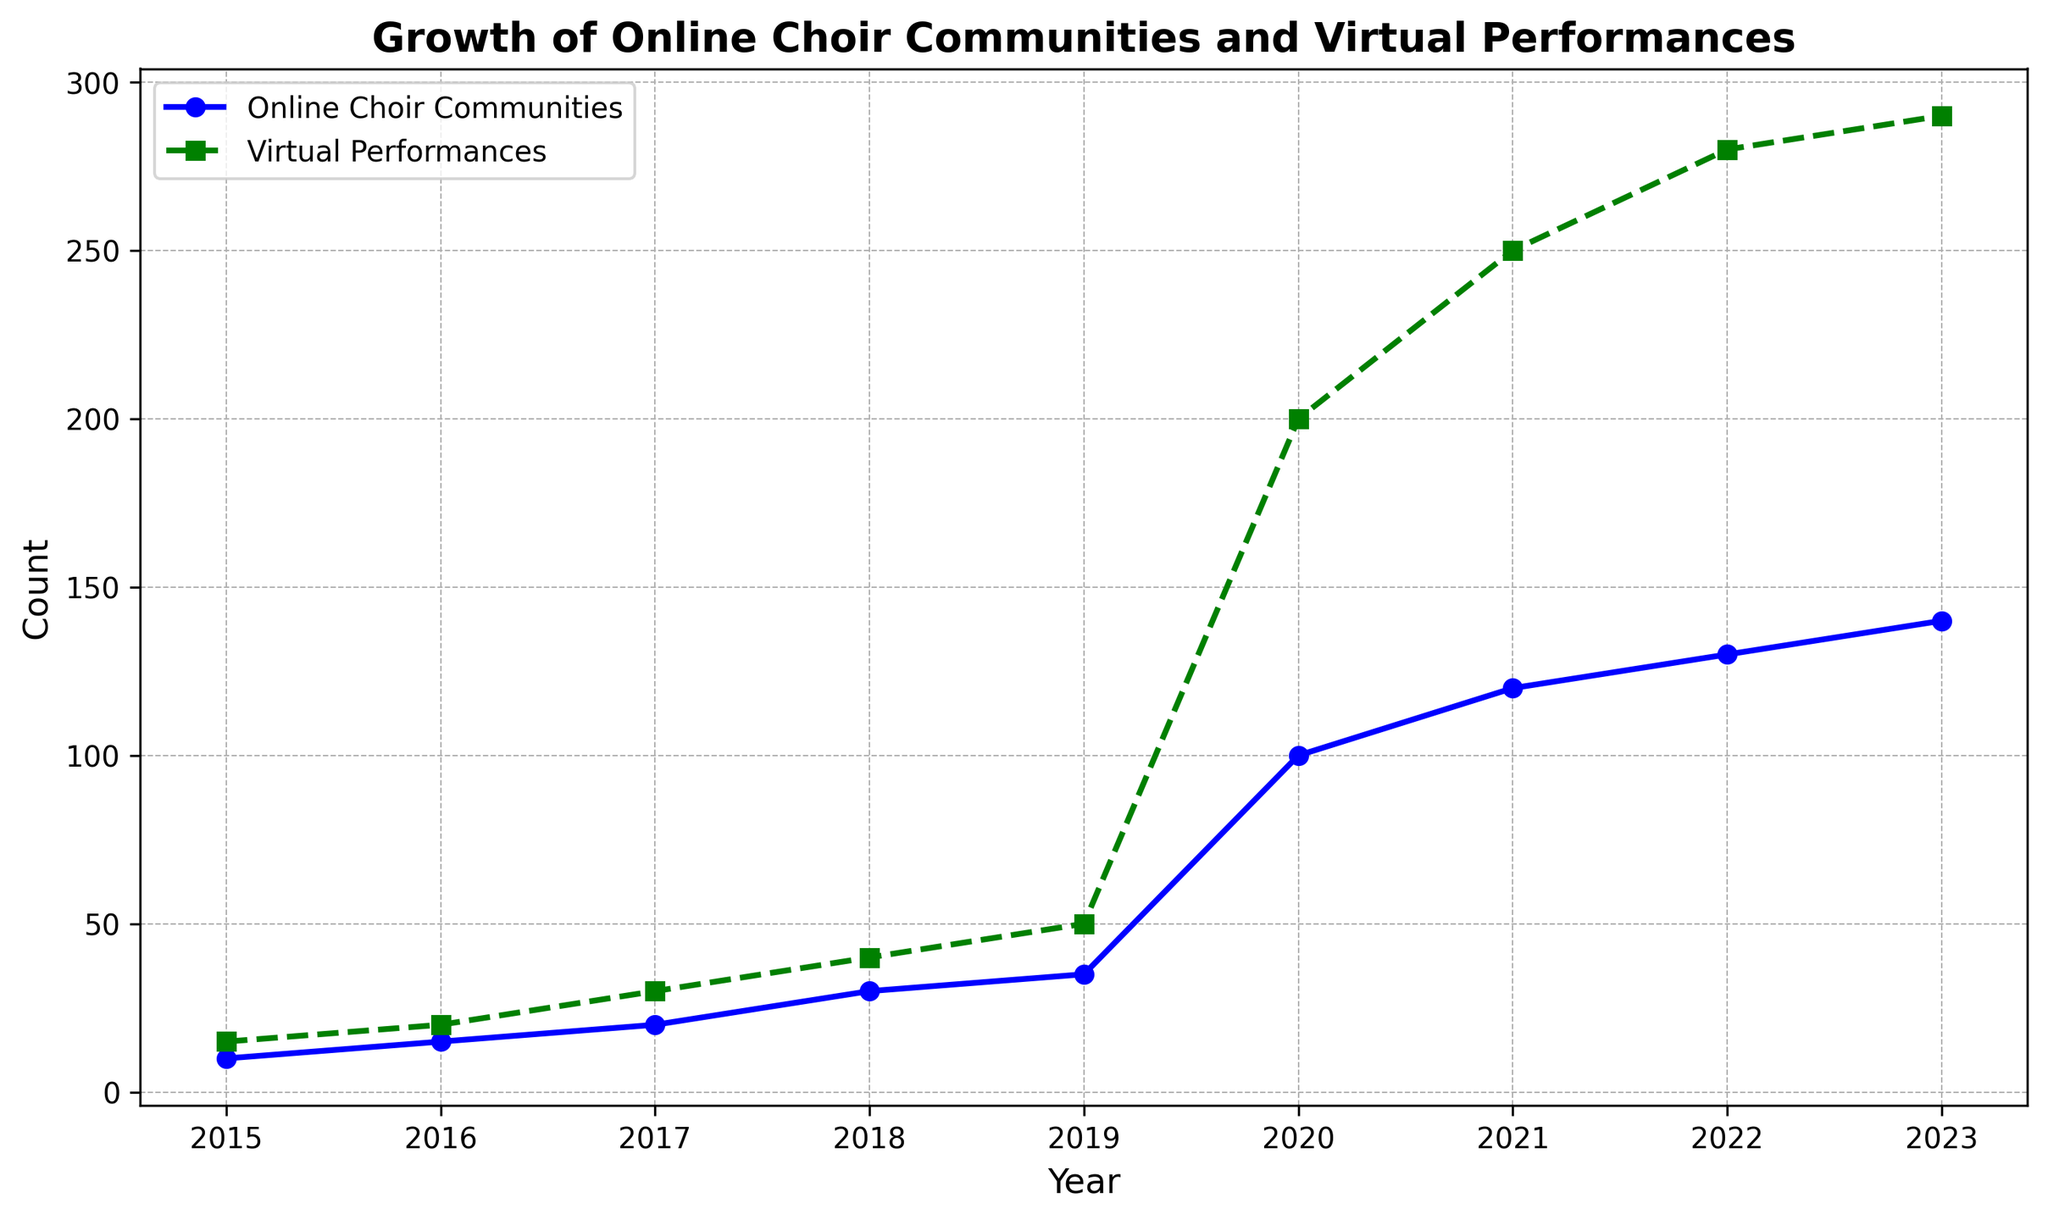What trend do you observe in the number of Online Choir Communities from 2015 to 2023? The number of Online Choir Communities steadily increases from 2015 to 2019, and then it shows a sharp increase from 2019 to 2020, followed by moderate growth till 2023.
Answer: The trend shows steady growth initially, a sharp increase in 2020, and then moderate growth Which year shows the steepest increase in the number of Virtual Performances? By observing the graph, the year 2020 shows a significant jump in the number of Virtual Performances more than any other year.
Answer: 2020 How many Online Choir Communities were there in 2018 and what was the number increase from 2018 to 2020? In 2018, there were 30 Online Choir Communities, and the number increased to 100 in 2020. To find the increase: 100 - 30 = 70.
Answer: 70 Compare the growth of Online Choir Communities and Virtual Performances between 2019 and 2020. Which had a higher growth rate? Online Choir Communities increased from 35 to 100, which is a growth of 65. Virtual Performances increased from 50 to 200, a growth of 150. While Virtual Performances had a higher numeric growth, the growth rate can be compared as follows: For Online Choir Communities: (100-35)/35 = 1.857 = 185.7%, and for Virtual Performances: (200-50)/50 = 3 = 300%. Virtual Performances had a higher growth rate.
Answer: Virtual Performances What visual cues can help you identify the different trends for Online Choir Communities and Virtual Performances? The Online Choir Communities are represented by a continuous blue line with circles, while Virtual Performances are represented by a dashed green line with squares. The different line styles and markers help distinguish the two trends.
Answer: Line styles and markers What is the difference in the number of Virtual Performances between 2021 and 2016? In 2016, there were 20 Virtual Performances, and in 2021, there were 250 Virtual Performances. The difference is 250 - 20 = 230.
Answer: 230 What was the average number of Online Choir Communities in the years prior to 2020? Online Choir Communities from 2015 to 2019 were: 10, 15, 20, 30, and 35. The sum of these values is 10 + 15 + 20 + 30 + 35 = 110. There are 5 years, so the average is 110 / 5 = 22.
Answer: 22 By how much did the total number of Virtual Performances increase from 2015 to 2023? The number of Virtual Performances in 2015 was 15, and in 2023 it was 290. The increase is 290 - 15 = 275.
Answer: 275 Which year first shows over 100 Online Choir Communities, and how many years did it take to reach that milestone? The year 2020 shows the first instance of over 100 Online Choir Communities. Starting from 2015, it took 5 years (2020 - 2015).
Answer: 2020, 5 years Which line, green or blue, shows more rapid growth in the plotted years? From the visual representation, the green dashed line (Virtual Performances) shows more rapid growth, especially around 2020, compared to the blue solid line (Online Choir Communities).
Answer: Green line 